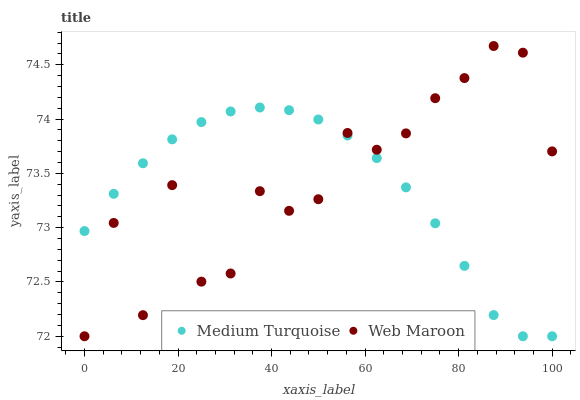Does Medium Turquoise have the minimum area under the curve?
Answer yes or no. Yes. Does Web Maroon have the maximum area under the curve?
Answer yes or no. Yes. Does Medium Turquoise have the maximum area under the curve?
Answer yes or no. No. Is Medium Turquoise the smoothest?
Answer yes or no. Yes. Is Web Maroon the roughest?
Answer yes or no. Yes. Is Medium Turquoise the roughest?
Answer yes or no. No. Does Web Maroon have the lowest value?
Answer yes or no. Yes. Does Web Maroon have the highest value?
Answer yes or no. Yes. Does Medium Turquoise have the highest value?
Answer yes or no. No. Does Medium Turquoise intersect Web Maroon?
Answer yes or no. Yes. Is Medium Turquoise less than Web Maroon?
Answer yes or no. No. Is Medium Turquoise greater than Web Maroon?
Answer yes or no. No. 